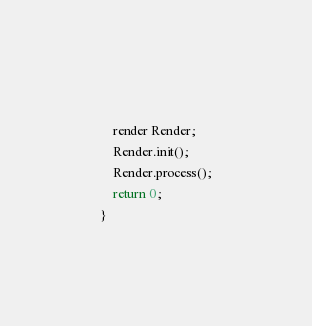<code> <loc_0><loc_0><loc_500><loc_500><_C++_>    
    render Render;
    Render.init();
    Render.process();
    return 0;
}
</code> 